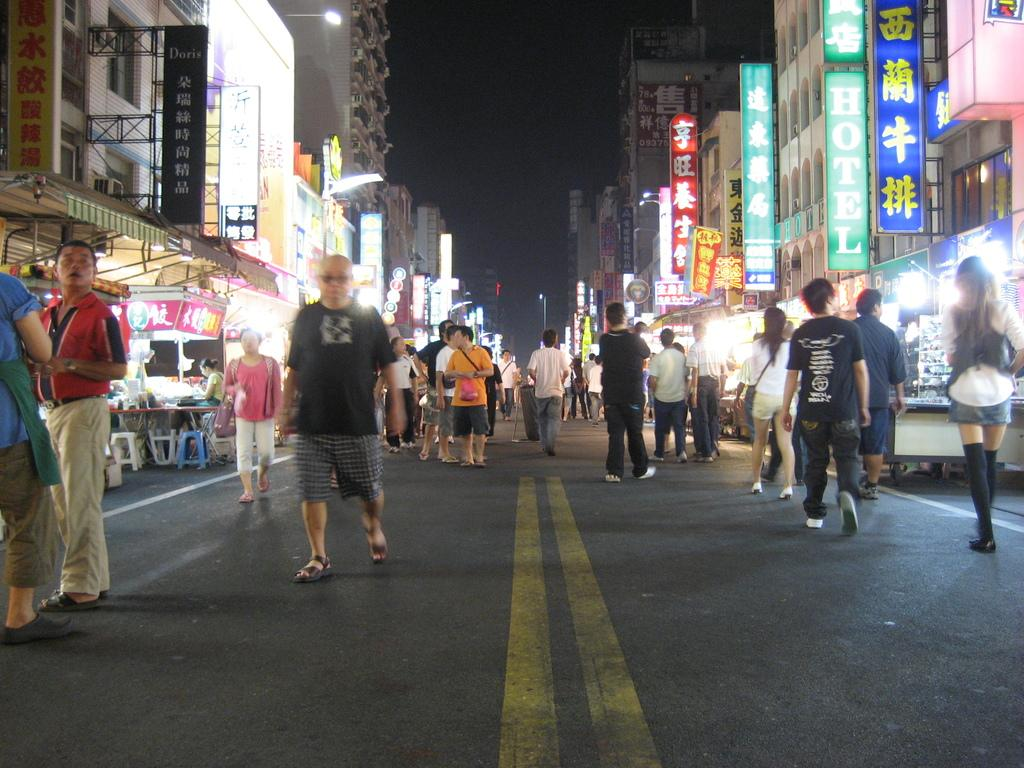What are the people in the image doing? The group of people is standing on the road. What furniture is visible in the image? There are chairs and a table in the image. What type of structures can be seen in the image? There are buildings in the image. What type of signage is present in the image? There are light boards in the image. What can be seen in the background of the image? The sky is visible in the background of the image. What type of lunch is being served on the table in the image? There is no lunch present in the image; it only shows a group of people standing on the road, chairs, a table, buildings, light boards, and the sky in the background. 